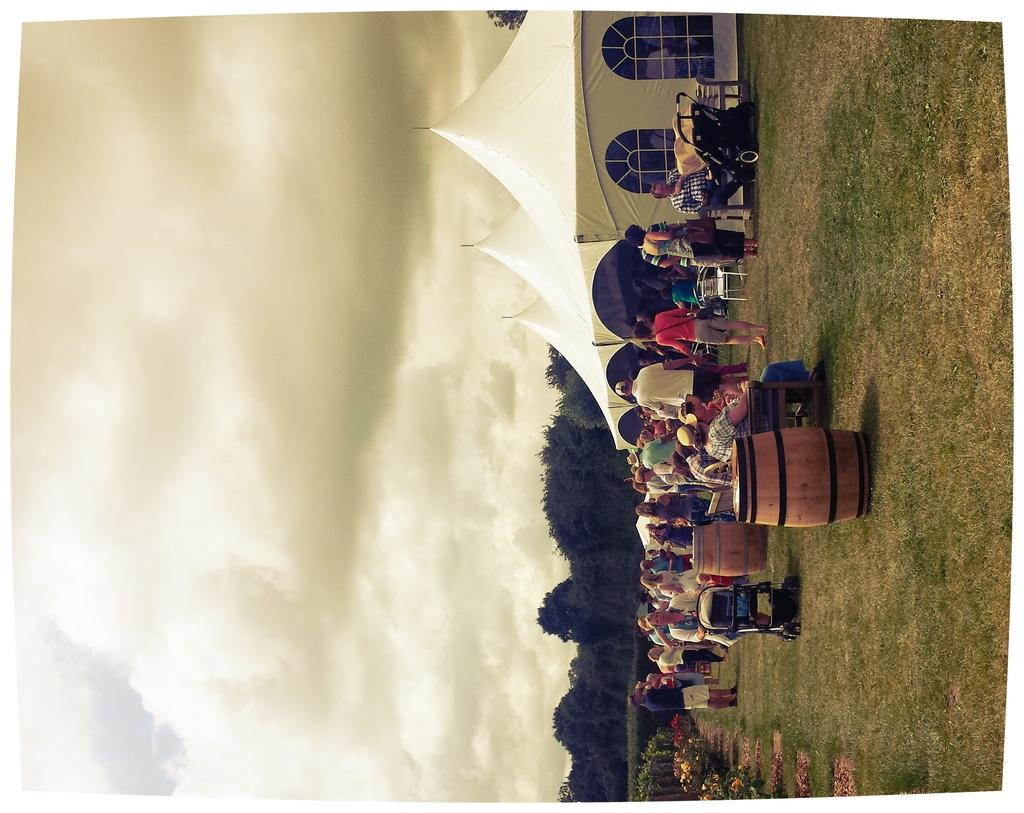What type of containers are present in the image? A: There are wooden barrels in the image. What type of temporary shelters can be seen in the image? There are tents in the image. What architectural feature is visible in the image? There are windows in the image. What type of transportation device for babies is present in the image? There are baby trolleys in the image. What type of vegetation is present in the image? There are trees in the image. Who or what is present in the image? There are people in the image. What can be seen in the sky in the image? There are clouds visible in the sky. What type of hook is used to hang the caption on the tents in the image? There is no hook or caption present in the image; it features wooden barrels, tents, windows, baby trolleys, trees, people, and clouds in the sky. What type of brush is used to paint the trees in the image? There is no brush or painting activity depicted in the image; the trees are natural vegetation. 